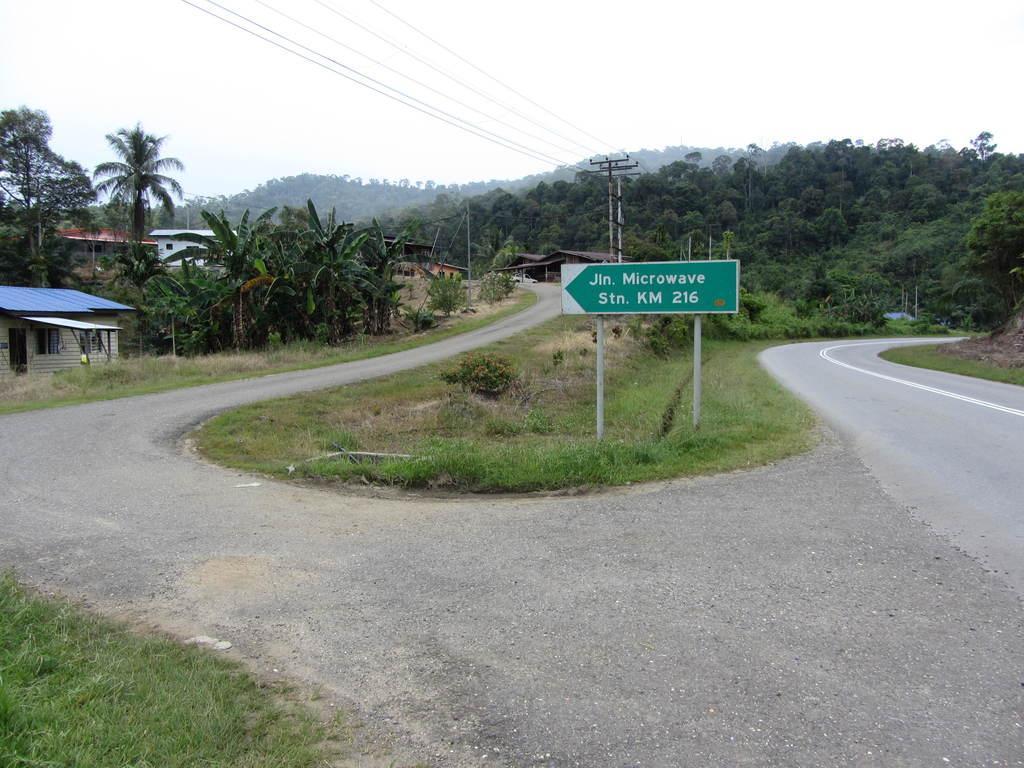In one or two sentences, can you explain what this image depicts? In this image we can see the houses, trees, grass, road and also the informational board. We can also see the electrical poles with wires. Sky is also visible. 